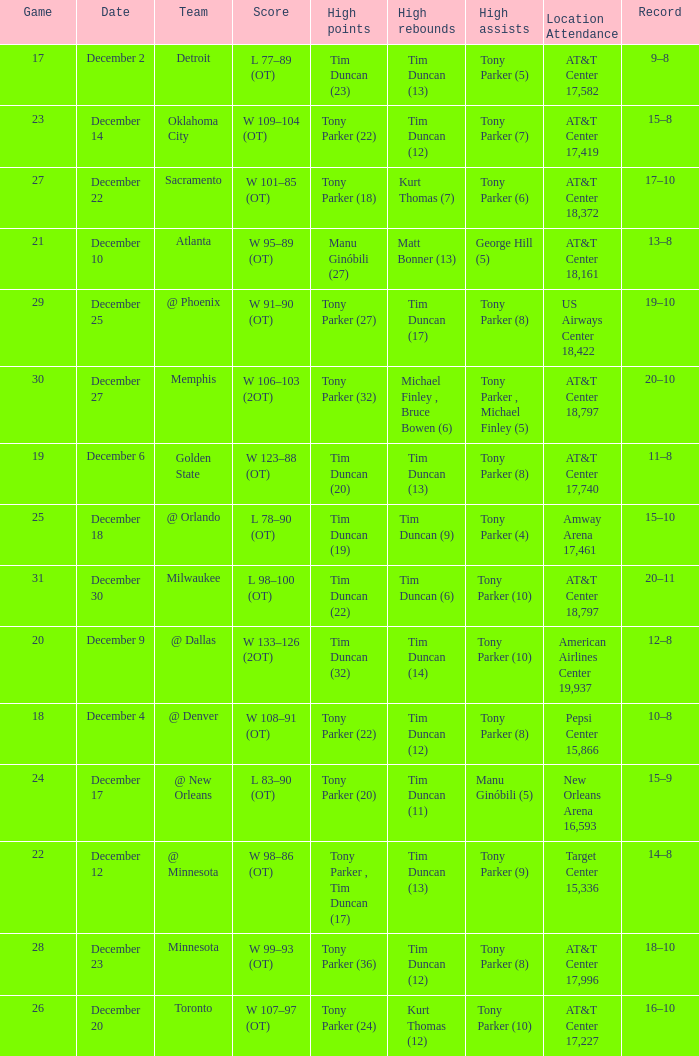What score has tim duncan (14) as the high rebounds? W 133–126 (2OT). Parse the full table. {'header': ['Game', 'Date', 'Team', 'Score', 'High points', 'High rebounds', 'High assists', 'Location Attendance', 'Record'], 'rows': [['17', 'December 2', 'Detroit', 'L 77–89 (OT)', 'Tim Duncan (23)', 'Tim Duncan (13)', 'Tony Parker (5)', 'AT&T Center 17,582', '9–8'], ['23', 'December 14', 'Oklahoma City', 'W 109–104 (OT)', 'Tony Parker (22)', 'Tim Duncan (12)', 'Tony Parker (7)', 'AT&T Center 17,419', '15–8'], ['27', 'December 22', 'Sacramento', 'W 101–85 (OT)', 'Tony Parker (18)', 'Kurt Thomas (7)', 'Tony Parker (6)', 'AT&T Center 18,372', '17–10'], ['21', 'December 10', 'Atlanta', 'W 95–89 (OT)', 'Manu Ginóbili (27)', 'Matt Bonner (13)', 'George Hill (5)', 'AT&T Center 18,161', '13–8'], ['29', 'December 25', '@ Phoenix', 'W 91–90 (OT)', 'Tony Parker (27)', 'Tim Duncan (17)', 'Tony Parker (8)', 'US Airways Center 18,422', '19–10'], ['30', 'December 27', 'Memphis', 'W 106–103 (2OT)', 'Tony Parker (32)', 'Michael Finley , Bruce Bowen (6)', 'Tony Parker , Michael Finley (5)', 'AT&T Center 18,797', '20–10'], ['19', 'December 6', 'Golden State', 'W 123–88 (OT)', 'Tim Duncan (20)', 'Tim Duncan (13)', 'Tony Parker (8)', 'AT&T Center 17,740', '11–8'], ['25', 'December 18', '@ Orlando', 'L 78–90 (OT)', 'Tim Duncan (19)', 'Tim Duncan (9)', 'Tony Parker (4)', 'Amway Arena 17,461', '15–10'], ['31', 'December 30', 'Milwaukee', 'L 98–100 (OT)', 'Tim Duncan (22)', 'Tim Duncan (6)', 'Tony Parker (10)', 'AT&T Center 18,797', '20–11'], ['20', 'December 9', '@ Dallas', 'W 133–126 (2OT)', 'Tim Duncan (32)', 'Tim Duncan (14)', 'Tony Parker (10)', 'American Airlines Center 19,937', '12–8'], ['18', 'December 4', '@ Denver', 'W 108–91 (OT)', 'Tony Parker (22)', 'Tim Duncan (12)', 'Tony Parker (8)', 'Pepsi Center 15,866', '10–8'], ['24', 'December 17', '@ New Orleans', 'L 83–90 (OT)', 'Tony Parker (20)', 'Tim Duncan (11)', 'Manu Ginóbili (5)', 'New Orleans Arena 16,593', '15–9'], ['22', 'December 12', '@ Minnesota', 'W 98–86 (OT)', 'Tony Parker , Tim Duncan (17)', 'Tim Duncan (13)', 'Tony Parker (9)', 'Target Center 15,336', '14–8'], ['28', 'December 23', 'Minnesota', 'W 99–93 (OT)', 'Tony Parker (36)', 'Tim Duncan (12)', 'Tony Parker (8)', 'AT&T Center 17,996', '18–10'], ['26', 'December 20', 'Toronto', 'W 107–97 (OT)', 'Tony Parker (24)', 'Kurt Thomas (12)', 'Tony Parker (10)', 'AT&T Center 17,227', '16–10']]} 